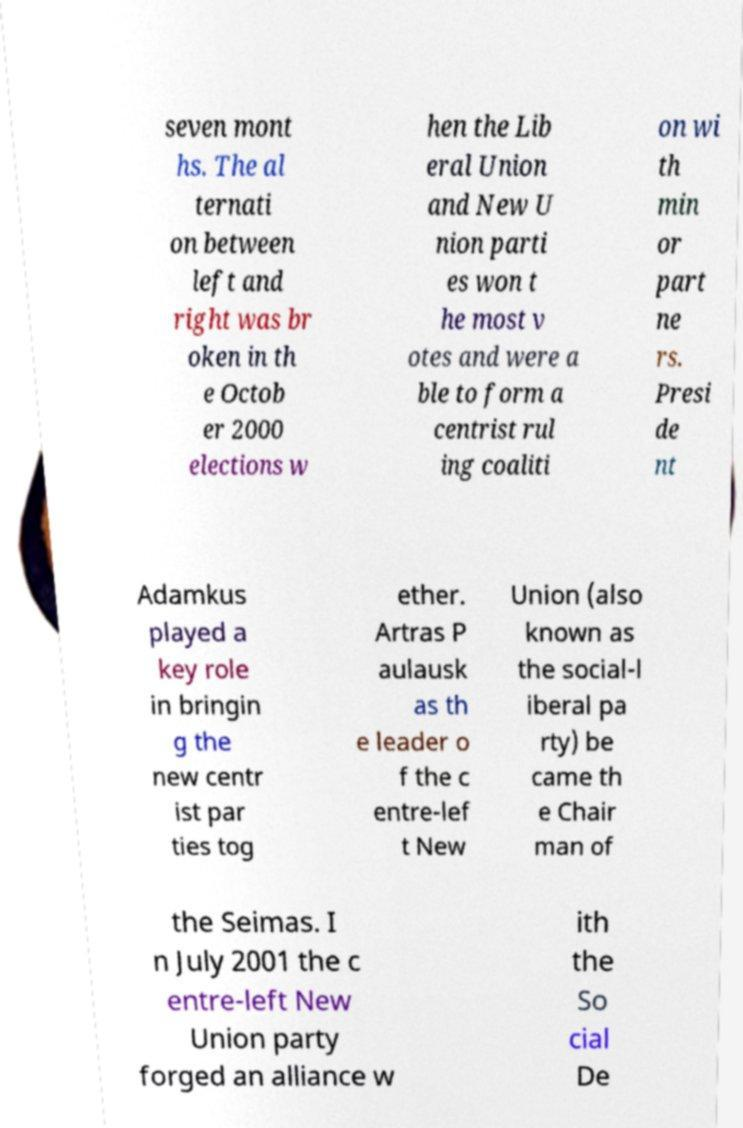Can you accurately transcribe the text from the provided image for me? seven mont hs. The al ternati on between left and right was br oken in th e Octob er 2000 elections w hen the Lib eral Union and New U nion parti es won t he most v otes and were a ble to form a centrist rul ing coaliti on wi th min or part ne rs. Presi de nt Adamkus played a key role in bringin g the new centr ist par ties tog ether. Artras P aulausk as th e leader o f the c entre-lef t New Union (also known as the social-l iberal pa rty) be came th e Chair man of the Seimas. I n July 2001 the c entre-left New Union party forged an alliance w ith the So cial De 